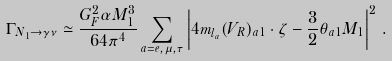Convert formula to latex. <formula><loc_0><loc_0><loc_500><loc_500>\Gamma _ { N _ { 1 } \rightarrow \gamma \nu } \simeq \frac { G _ { F } ^ { 2 } \alpha M _ { 1 } ^ { 3 } } { 6 4 \pi ^ { 4 } } \sum _ { a = e , \mu , \tau } \left | 4 m _ { l _ { a } } ( V _ { R } ) _ { a 1 } \cdot \zeta - \frac { 3 } { 2 } \theta _ { a 1 } M _ { 1 } \right | ^ { 2 } \, .</formula> 